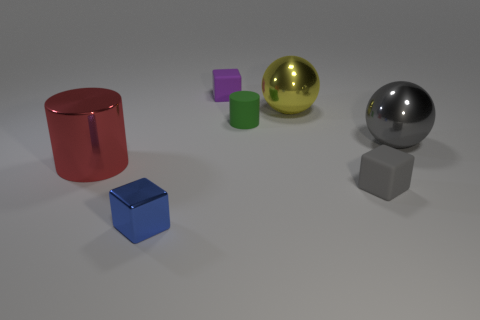Add 3 green objects. How many objects exist? 10 Subtract all cylinders. How many objects are left? 5 Subtract all metal objects. Subtract all gray cubes. How many objects are left? 2 Add 2 tiny purple matte cubes. How many tiny purple matte cubes are left? 3 Add 5 gray spheres. How many gray spheres exist? 6 Subtract 1 purple cubes. How many objects are left? 6 